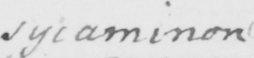Can you read and transcribe this handwriting? sycaminon 